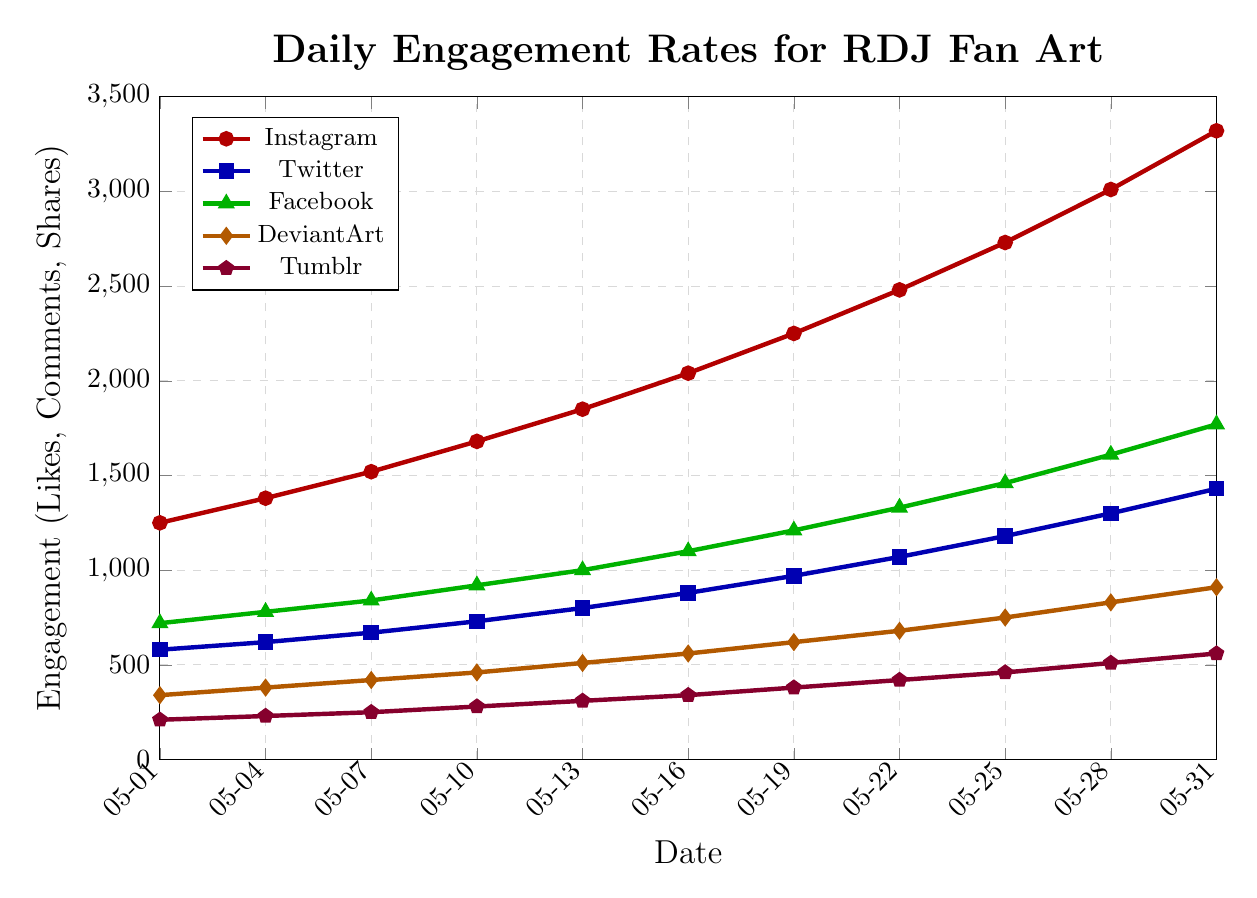What is the date when engagement on Instagram surpassed 3000? Identify the points on the line chart for Instagram and find the date right after the value crosses 3000.
Answer: May 28, 2023 Which social media platform had the lowest engagement on May 31? Compare the engagement rates for all platforms on May 31 by looking at the heights of the lines at the final point.
Answer: Tumblr How many days did it take for Facebook to reach an engagement rate of 1000? Identify the date when Facebook's engagement rate reaches 1000 and count the number of days from the start.
Answer: 12 days By how much did Twitter's engagement rate increase from May 1 to May 31? Subtract the engagement rate of Twitter on May 1 from the engagement rate on May 31.
Answer: 850 Which platform had the steepest increase in engagement between May 13 and May 19? Compare the slopes of the lines for all platforms between May 13 and May 19.
Answer: Instagram What's the average engagement rate on DeviantArt over the month? Add all DeviantArt engagement rates and divide by the number of data points (10).
Answer: 640 Which platform showed the most consistent increase in engagement over the month? Observe the smoothness and steadiness of the slopes in the lines for each platform throughout the month.
Answer: Tumblr How does the engagement rate on May 10 for Twitter compare to May 25 for DeviantArt? Compare the engagement rate of Twitter on May 10 with the rate of DeviantArt on May 25 by looking at the respective points.
Answer: Twitter (May 10) is 730, DeviantArt (May 25) is 750 What is the sum of engagement rates across all platforms on May 22? Add the engagement rates for Instagram, Twitter, Facebook, DeviantArt, and Tumblr on May 22.
Answer: 5980 Which platform had the smallest increase in engagement from May 19 to May 31? Calculate the difference in engagement for all platforms from May 19 to May 31 and find the smallest one.
Answer: Tumblr 